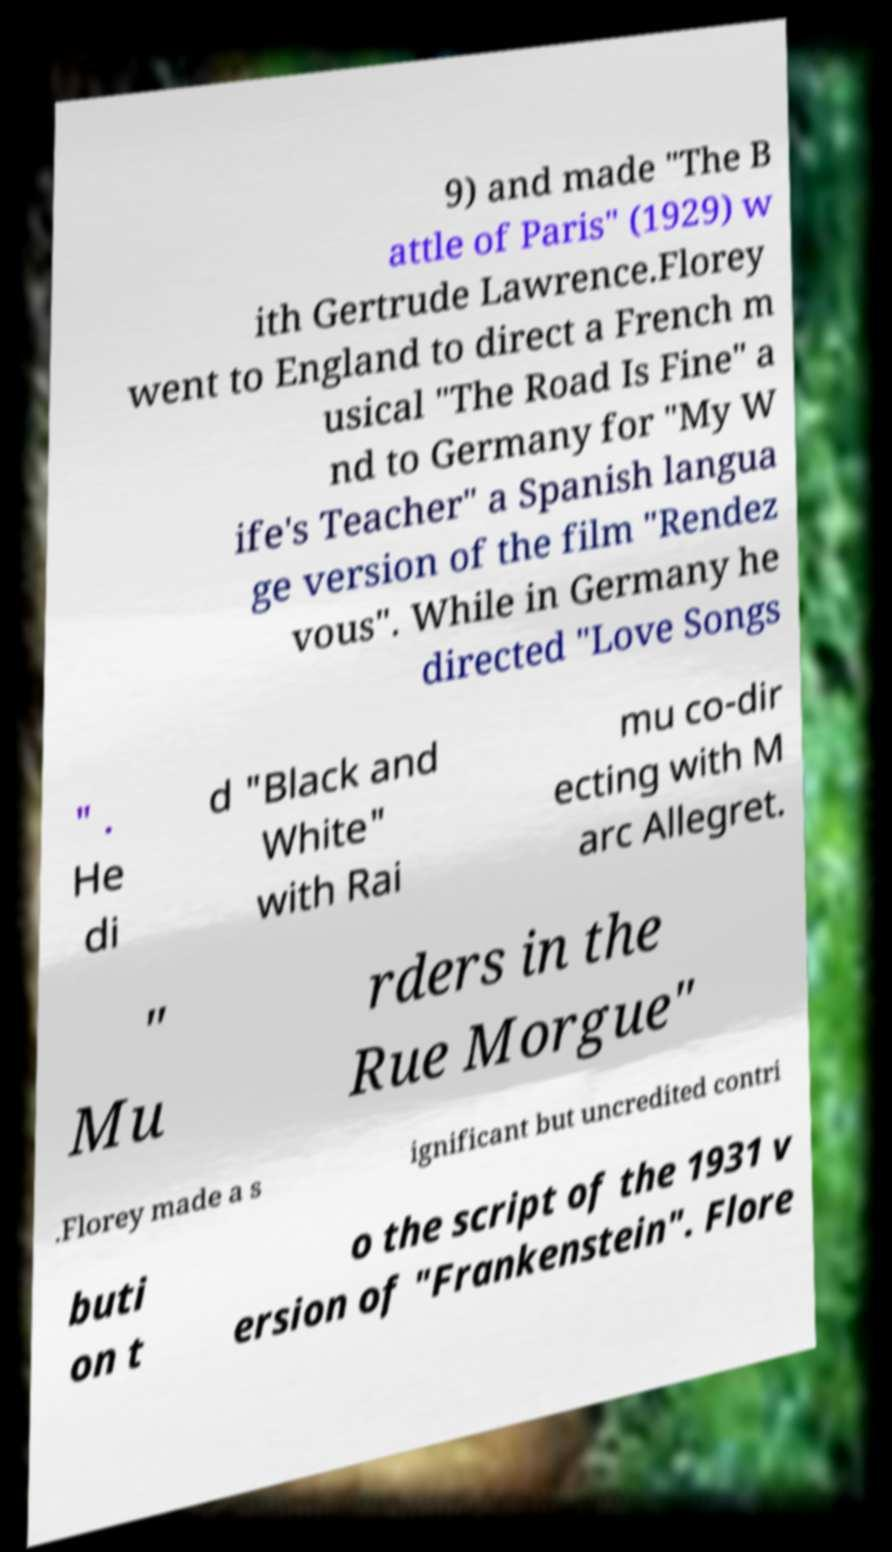Can you accurately transcribe the text from the provided image for me? 9) and made "The B attle of Paris" (1929) w ith Gertrude Lawrence.Florey went to England to direct a French m usical "The Road Is Fine" a nd to Germany for "My W ife's Teacher" a Spanish langua ge version of the film "Rendez vous". While in Germany he directed "Love Songs " . He di d "Black and White" with Rai mu co-dir ecting with M arc Allegret. " Mu rders in the Rue Morgue" .Florey made a s ignificant but uncredited contri buti on t o the script of the 1931 v ersion of "Frankenstein". Flore 